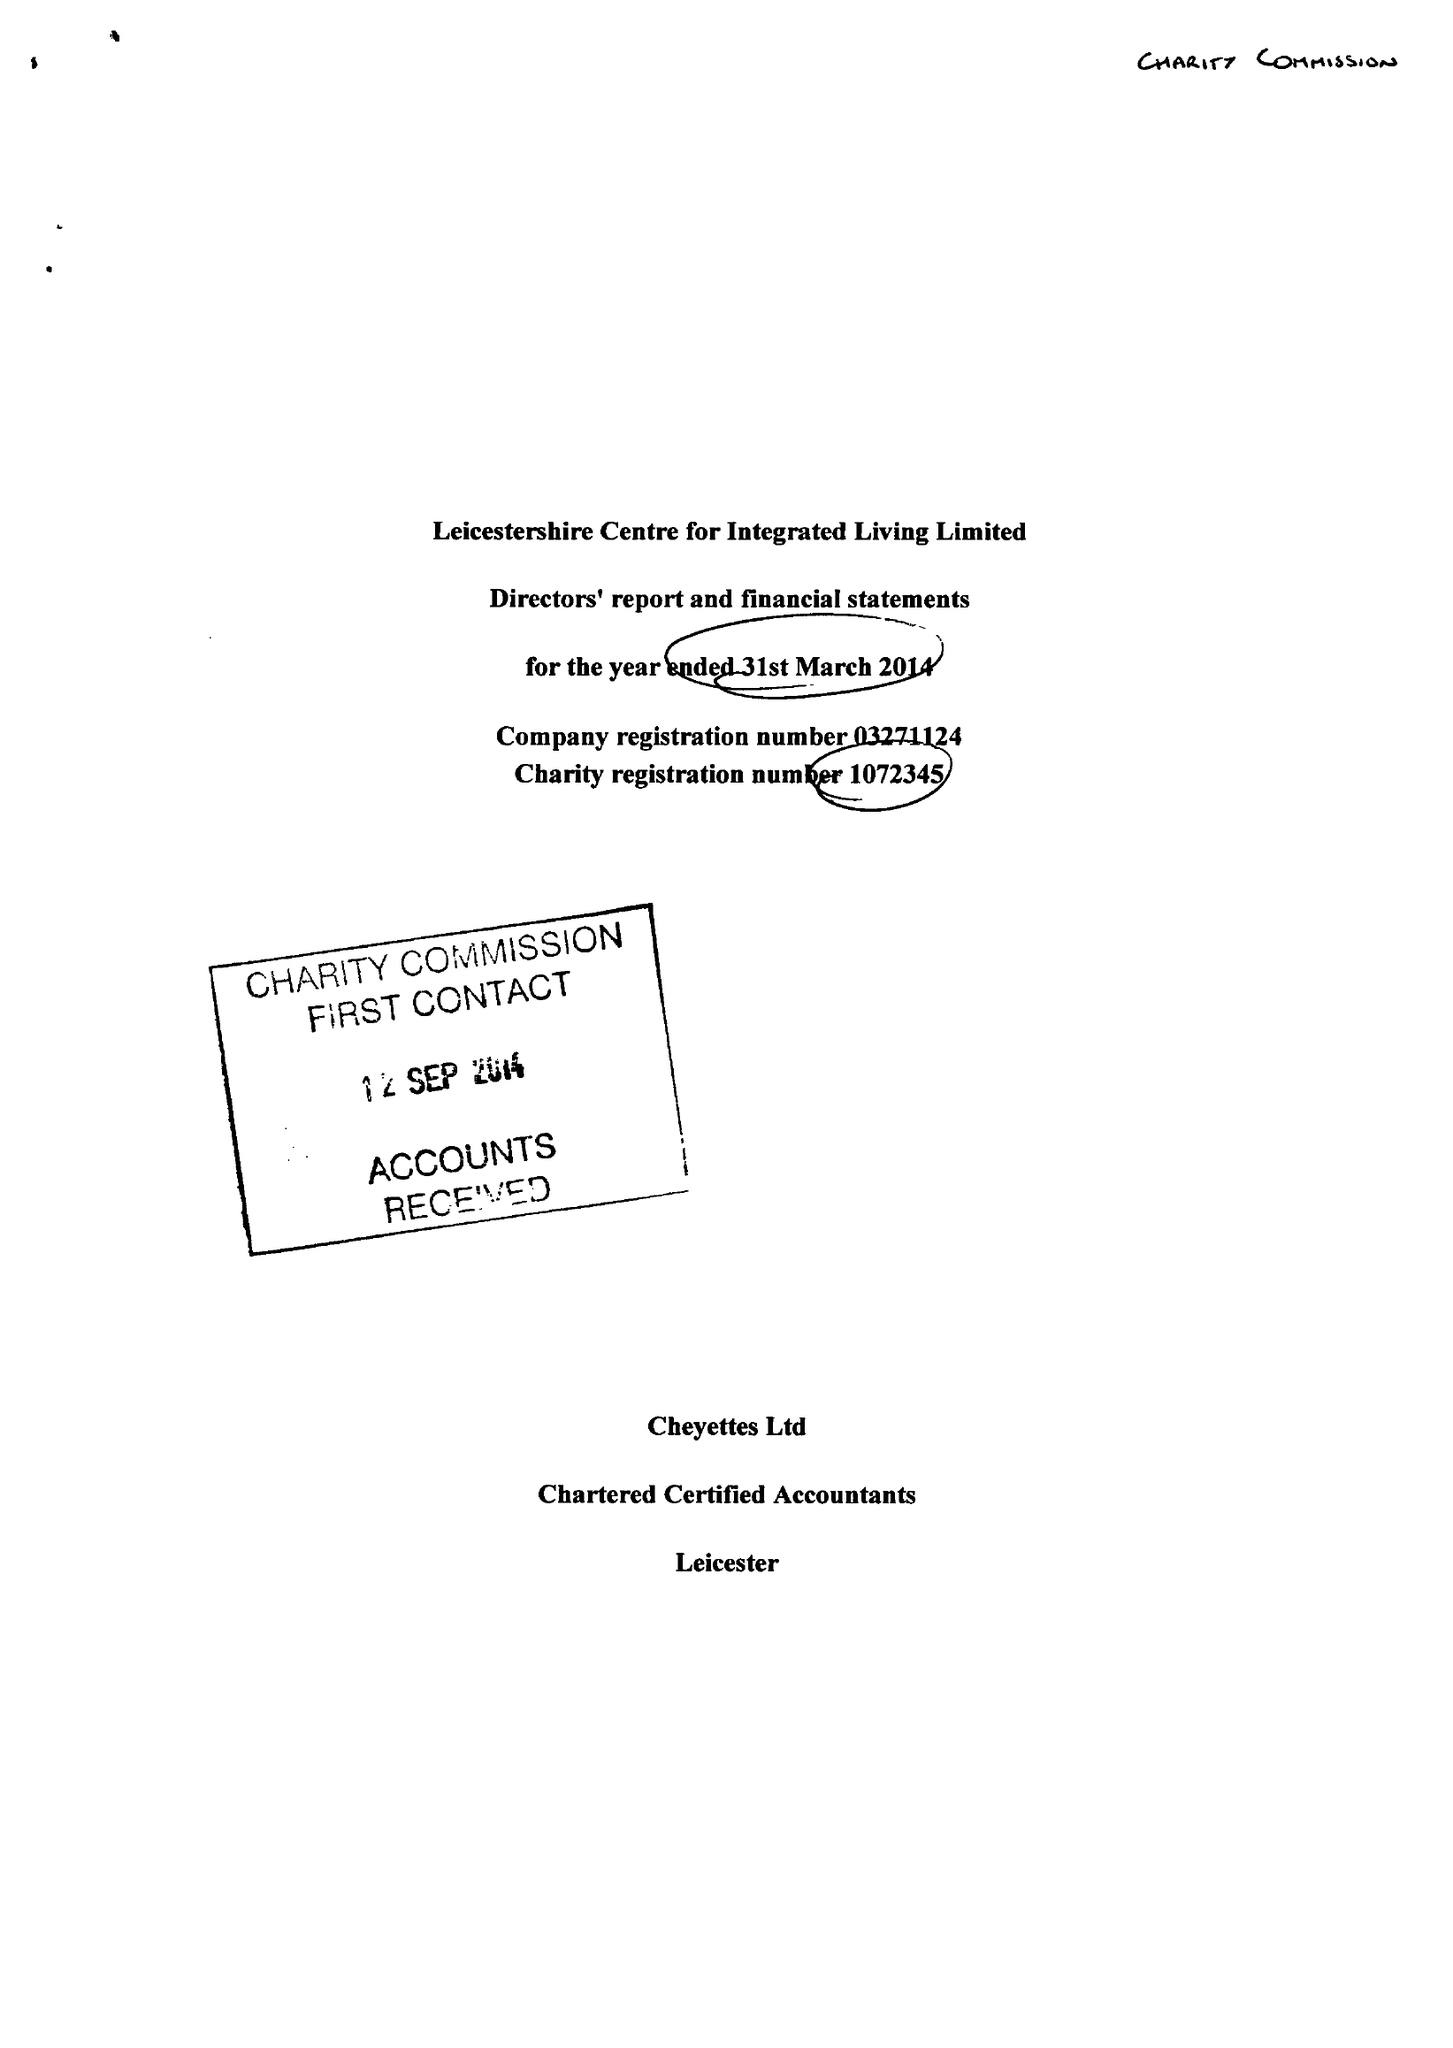What is the value for the report_date?
Answer the question using a single word or phrase. 2014-03-31 